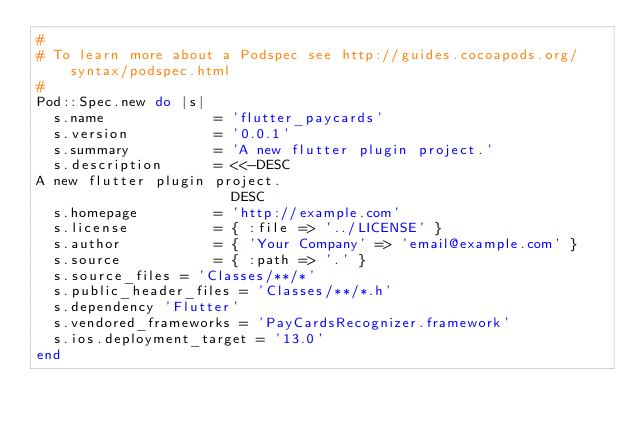<code> <loc_0><loc_0><loc_500><loc_500><_Ruby_>#
# To learn more about a Podspec see http://guides.cocoapods.org/syntax/podspec.html
#
Pod::Spec.new do |s|
  s.name             = 'flutter_paycards'
  s.version          = '0.0.1'
  s.summary          = 'A new flutter plugin project.'
  s.description      = <<-DESC
A new flutter plugin project.
                       DESC
  s.homepage         = 'http://example.com'
  s.license          = { :file => '../LICENSE' }
  s.author           = { 'Your Company' => 'email@example.com' }
  s.source           = { :path => '.' }
  s.source_files = 'Classes/**/*'
  s.public_header_files = 'Classes/**/*.h'
  s.dependency 'Flutter'
  s.vendored_frameworks = 'PayCardsRecognizer.framework'
  s.ios.deployment_target = '13.0'
end

</code> 